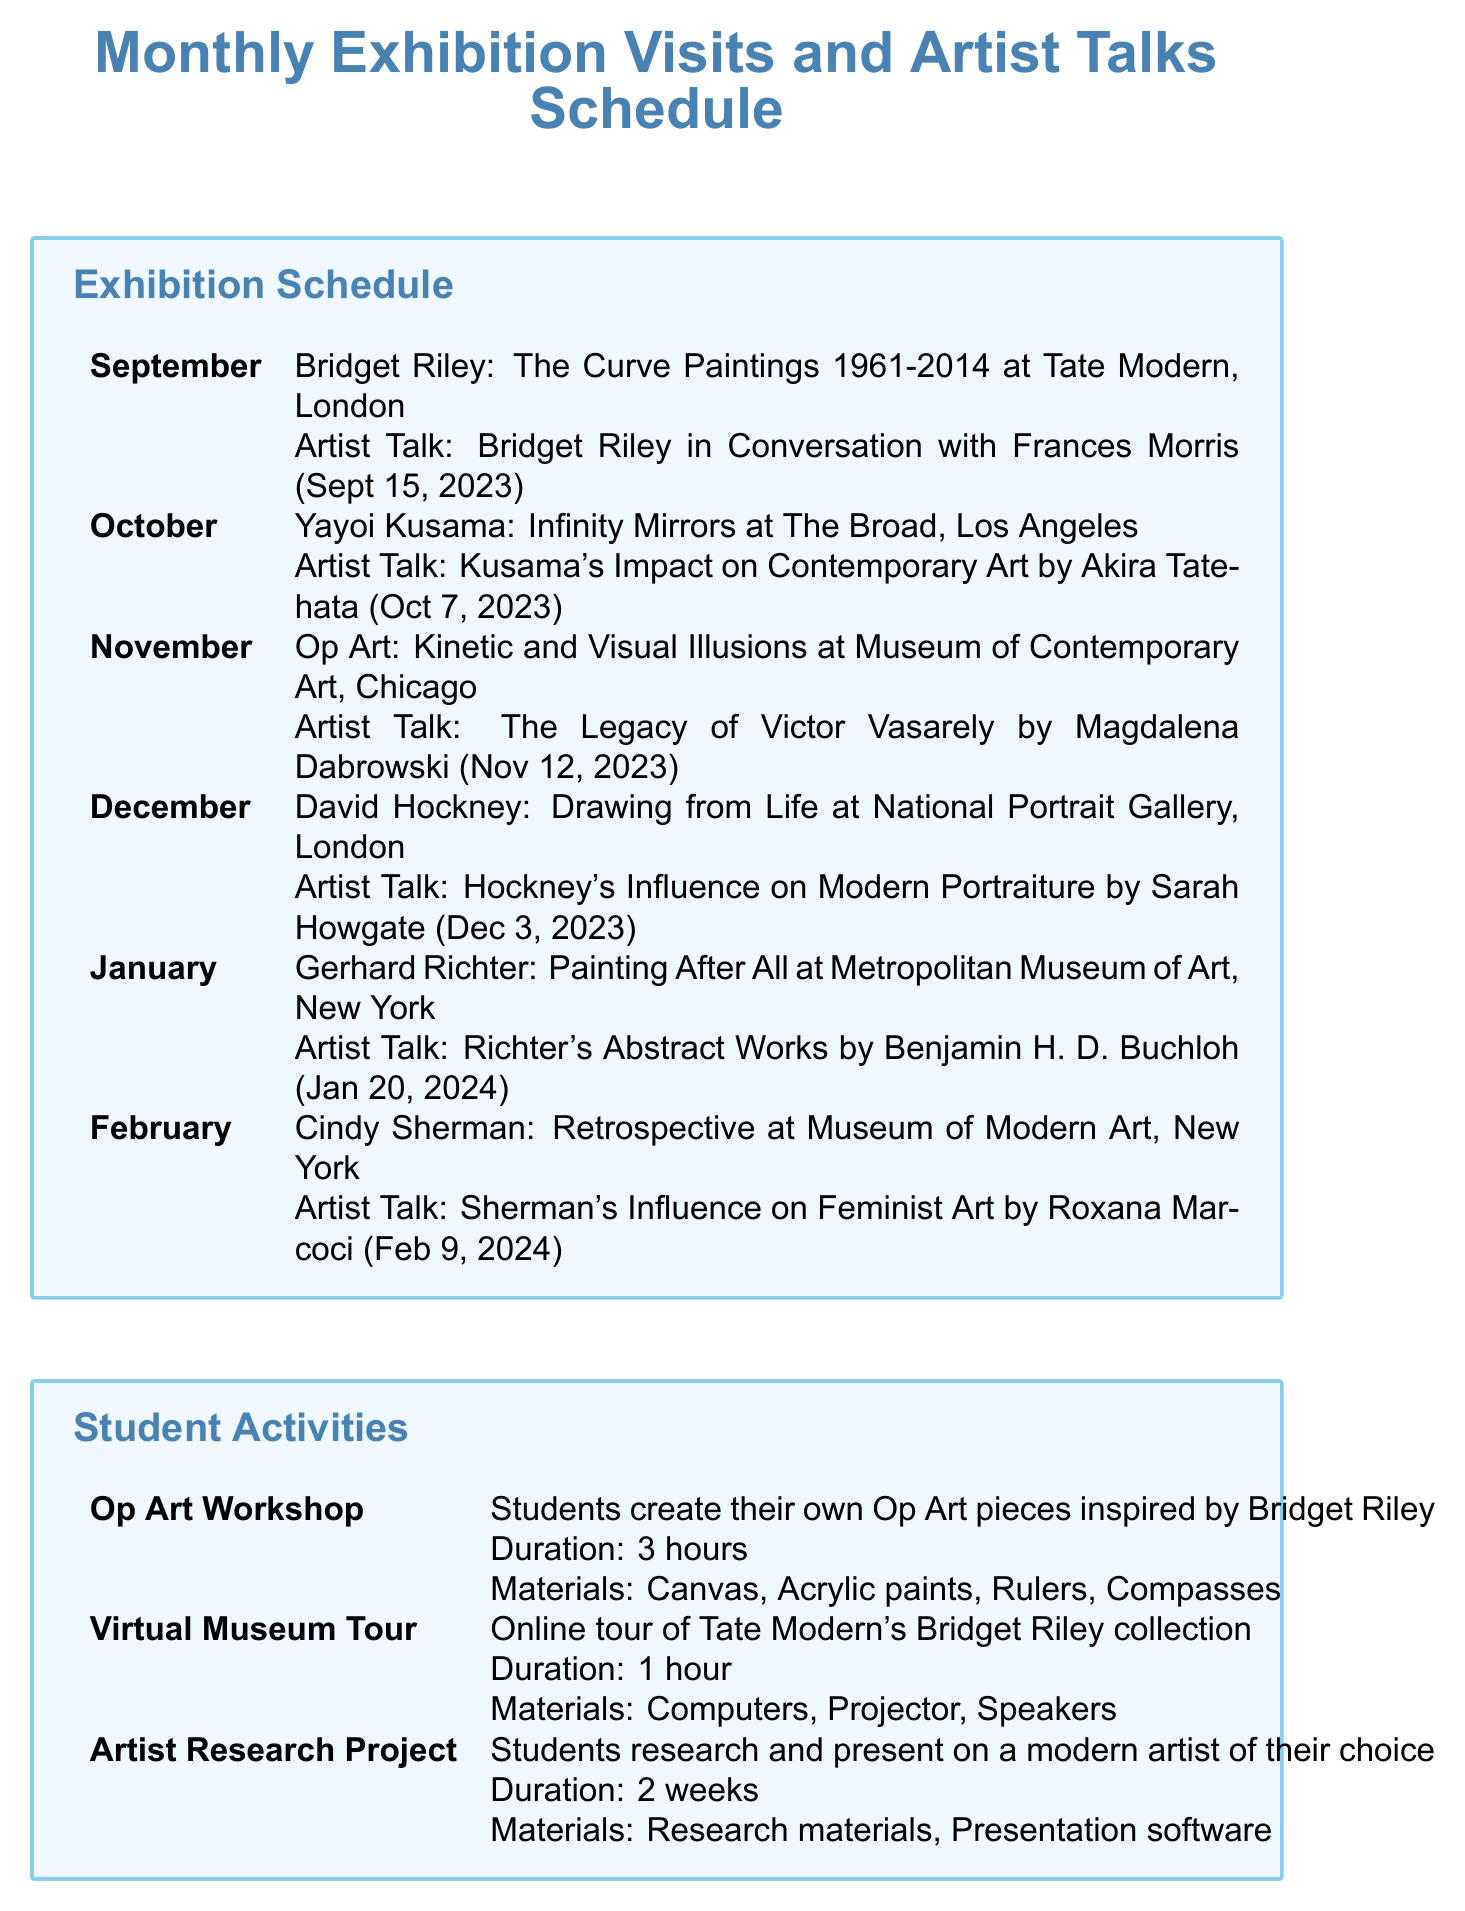What is the exhibition for September? The document lists the exhibition for September as "Bridget Riley: The Curve Paintings 1961-2014."
Answer: Bridget Riley: The Curve Paintings 1961-2014 Who is the speaker for the artist talk in November? The artist talk in November features Magdalena Dabrowski discussing Victor Vasarely's legacy.
Answer: Magdalena Dabrowski When is the artist talk for the October exhibition? The document specifies that the artist talk for the October exhibition is on October 7, 2023.
Answer: October 7, 2023 What is the duration of the Op Art Workshop? The Op Art Workshop is listed in the document with a duration of 3 hours.
Answer: 3 hours Which artist is featured in February's exhibition? The February exhibition focuses on "Cindy Sherman: Retrospective," according to the document.
Answer: Cindy Sherman How many acrylic paint sets are currently in inventory? The inventory shows there are 30 acrylic paint sets available.
Answer: 30 Which venue will host the David Hockney exhibition? The document states that the David Hockney exhibition will be at the National Portrait Gallery in London.
Answer: National Portrait Gallery, London What is the focus of the October professional development event? According to the document, the focus of the October event is on incorporating contemporary art into high school curricula.
Answer: Incorporating contemporary art into high school curricula Where is the January workshop on Bridget Riley taking place? The workshop on Bridget Riley is set to occur at the Royal Academy of Arts in London.
Answer: Royal Academy of Arts, London 